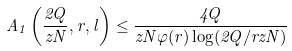<formula> <loc_0><loc_0><loc_500><loc_500>A _ { 1 } \left ( \frac { 2 Q } { z N } , r , l \right ) \leq \frac { 4 Q } { z N \varphi ( r ) \log ( 2 Q / r z N ) }</formula> 